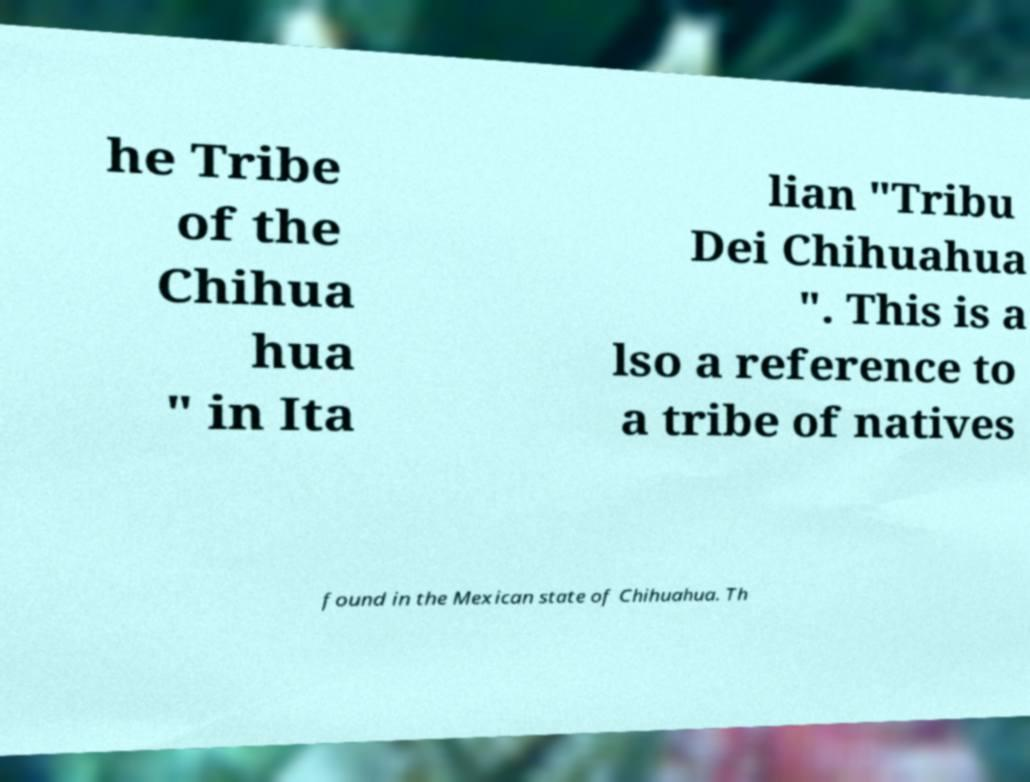Can you read and provide the text displayed in the image?This photo seems to have some interesting text. Can you extract and type it out for me? he Tribe of the Chihua hua " in Ita lian "Tribu Dei Chihuahua ". This is a lso a reference to a tribe of natives found in the Mexican state of Chihuahua. Th 